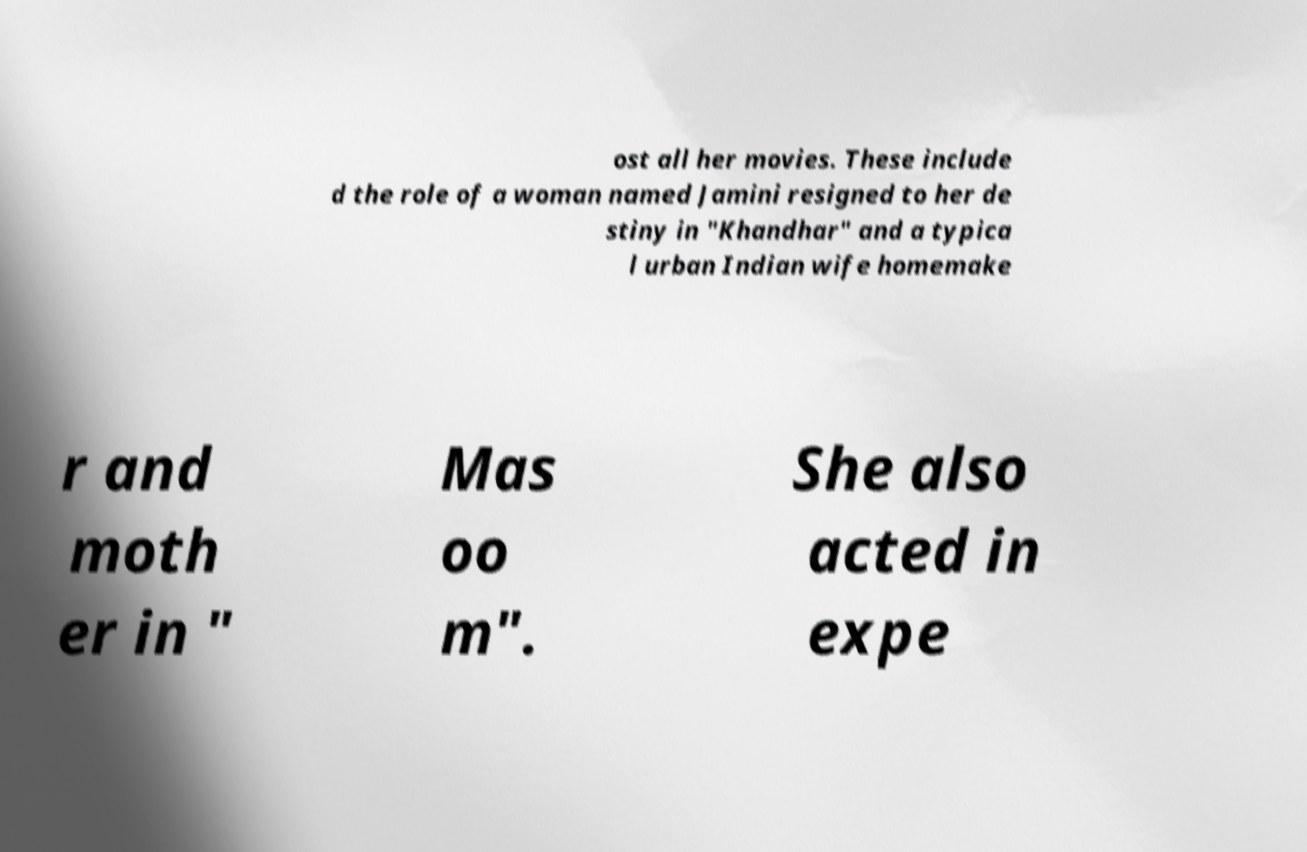For documentation purposes, I need the text within this image transcribed. Could you provide that? ost all her movies. These include d the role of a woman named Jamini resigned to her de stiny in "Khandhar" and a typica l urban Indian wife homemake r and moth er in " Mas oo m". She also acted in expe 